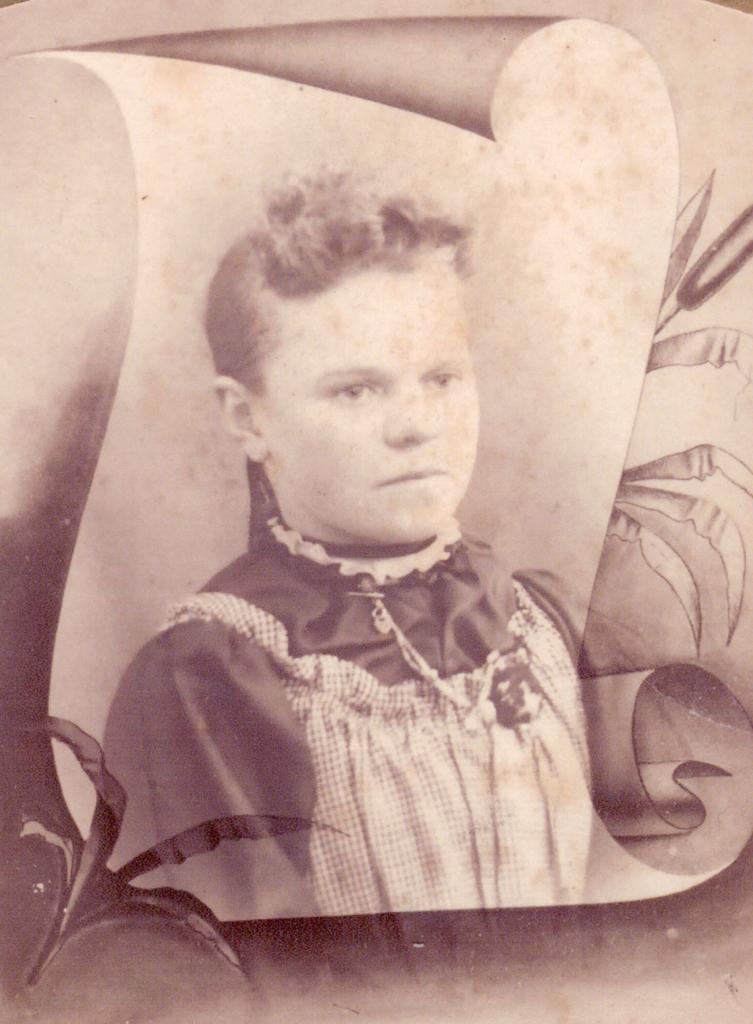Could you give a brief overview of what you see in this image? It is a edited image. In this image we can see a picture of a person. 